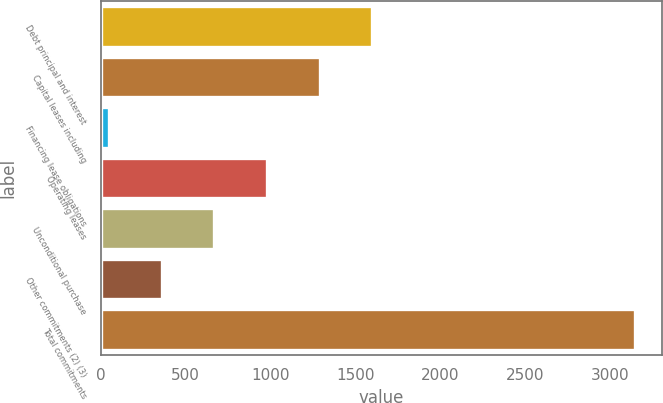Convert chart to OTSL. <chart><loc_0><loc_0><loc_500><loc_500><bar_chart><fcel>Debt principal and interest<fcel>Capital leases including<fcel>Financing lease obligations<fcel>Operating leases<fcel>Unconditional purchase<fcel>Other commitments (2) (3)<fcel>Total commitments<nl><fcel>1600<fcel>1289.6<fcel>48<fcel>979.2<fcel>668.8<fcel>358.4<fcel>3152<nl></chart> 